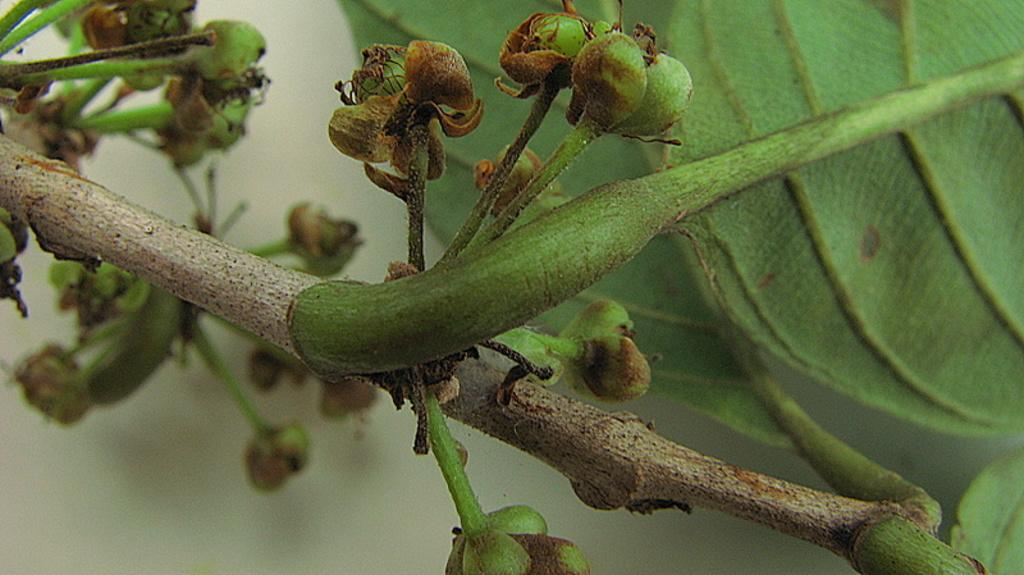What is present in the picture? There is a plant in the picture. What stage of growth are the plant's buds in? The plant has buds, which suggests it is in the process of blooming. What part of the plant is visible in the image? The plant has a leaf visible in the image. What color is the background of the picture? The background of the picture is white. What type of brass instrument can be seen in the picture? There is no brass instrument present in the picture; it features a plant with buds and a leaf. How many beetles are crawling on the plant in the picture? There are no beetles present in the picture; it only features a plant with buds and a leaf. 